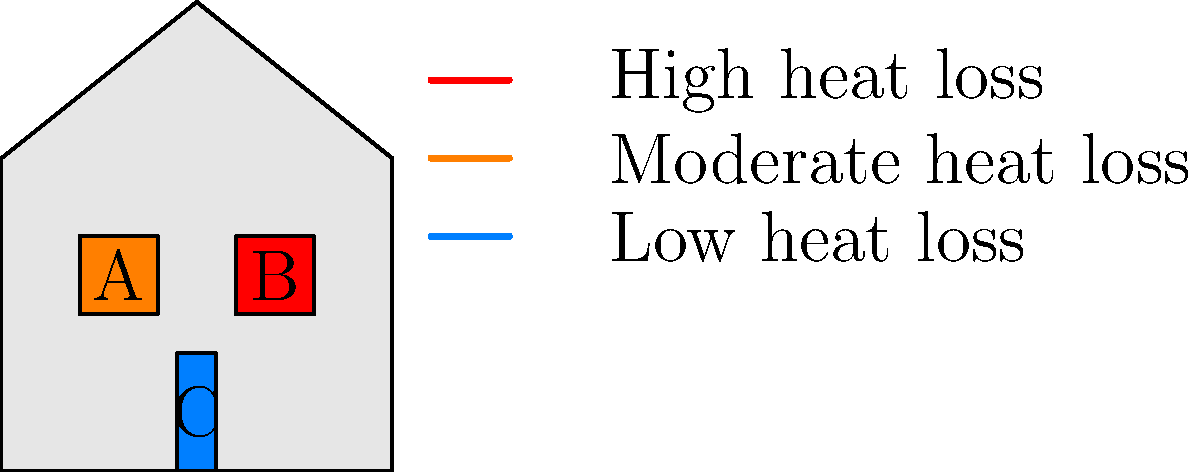Based on the thermal imaging diagram of a house, which area(s) should be prioritized for inspection and potential improvement to enhance energy efficiency? To answer this question, we need to analyze the thermal imaging diagram and interpret the color coding:

1. Understand the color coding:
   - Red indicates high heat loss
   - Orange indicates moderate heat loss
   - Blue indicates low heat loss

2. Examine the different areas of the house:
   - Area A (left window): Orange, indicating moderate heat loss
   - Area B (right window): Red, indicating high heat loss
   - Area C (door): Blue, indicating low heat loss

3. Prioritize areas based on heat loss:
   - High heat loss areas should be addressed first, as they contribute most to energy inefficiency
   - Moderate heat loss areas should be addressed next
   - Low heat loss areas are already performing well and don't require immediate attention

4. Identify the priority area:
   - Area B (right window) shows the highest heat loss and should be prioritized for inspection and improvement

5. Consider secondary priorities:
   - Area A (left window) shows moderate heat loss and should be addressed after Area B

6. Note well-performing areas:
   - Area C (door) shows low heat loss and doesn't require immediate attention

Based on this analysis, the area that should be prioritized for inspection and potential improvement is Area B, the right window, as it shows the highest heat loss in the thermal imaging diagram.
Answer: Area B (right window) 